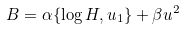<formula> <loc_0><loc_0><loc_500><loc_500>B = \alpha \{ \log H , u _ { 1 } \} + \beta u ^ { 2 }</formula> 